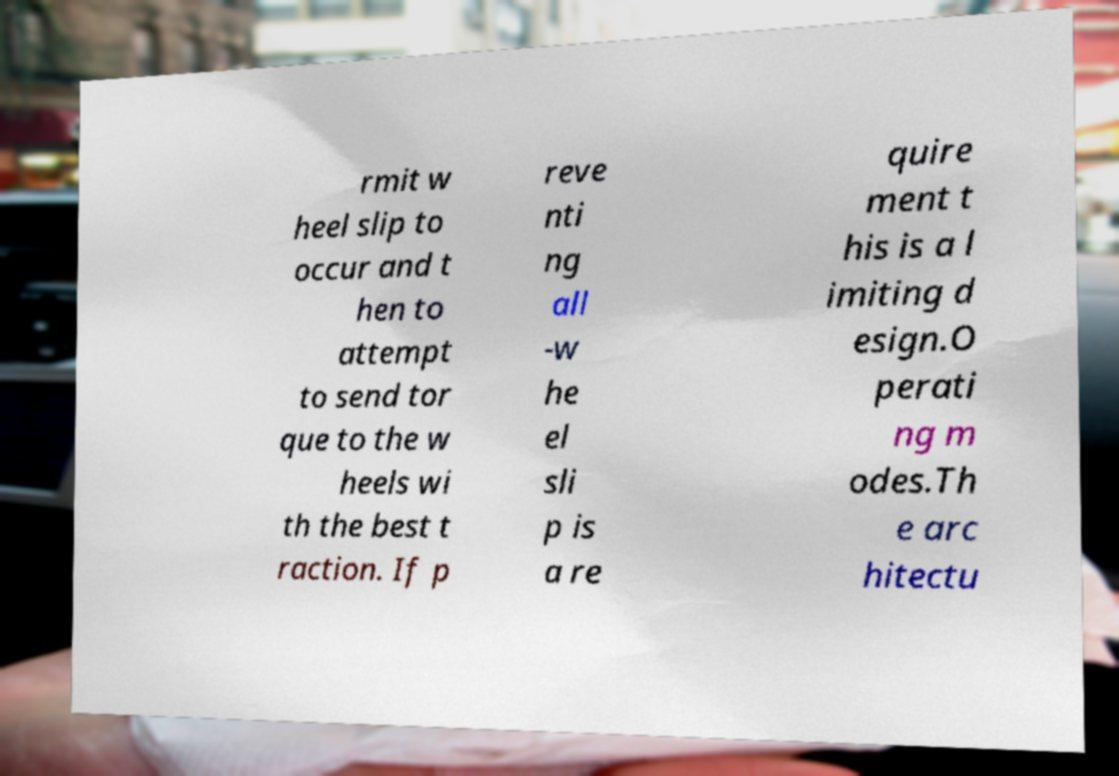For documentation purposes, I need the text within this image transcribed. Could you provide that? rmit w heel slip to occur and t hen to attempt to send tor que to the w heels wi th the best t raction. If p reve nti ng all -w he el sli p is a re quire ment t his is a l imiting d esign.O perati ng m odes.Th e arc hitectu 